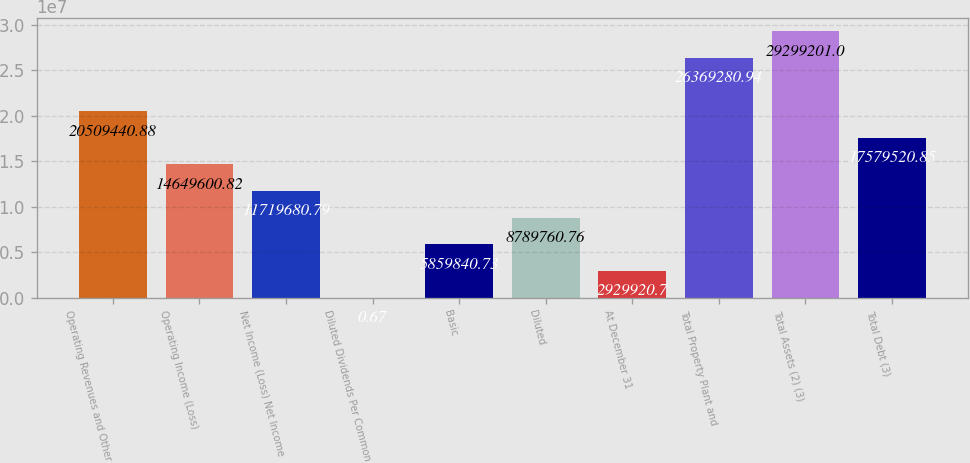Convert chart to OTSL. <chart><loc_0><loc_0><loc_500><loc_500><bar_chart><fcel>Operating Revenues and Other<fcel>Operating Income (Loss)<fcel>Net Income (Loss) Net Income<fcel>Diluted Dividends Per Common<fcel>Basic<fcel>Diluted<fcel>At December 31<fcel>Total Property Plant and<fcel>Total Assets (2) (3)<fcel>Total Debt (3)<nl><fcel>2.05094e+07<fcel>1.46496e+07<fcel>1.17197e+07<fcel>0.67<fcel>5.85984e+06<fcel>8.78976e+06<fcel>2.92992e+06<fcel>2.63693e+07<fcel>2.92992e+07<fcel>1.75795e+07<nl></chart> 